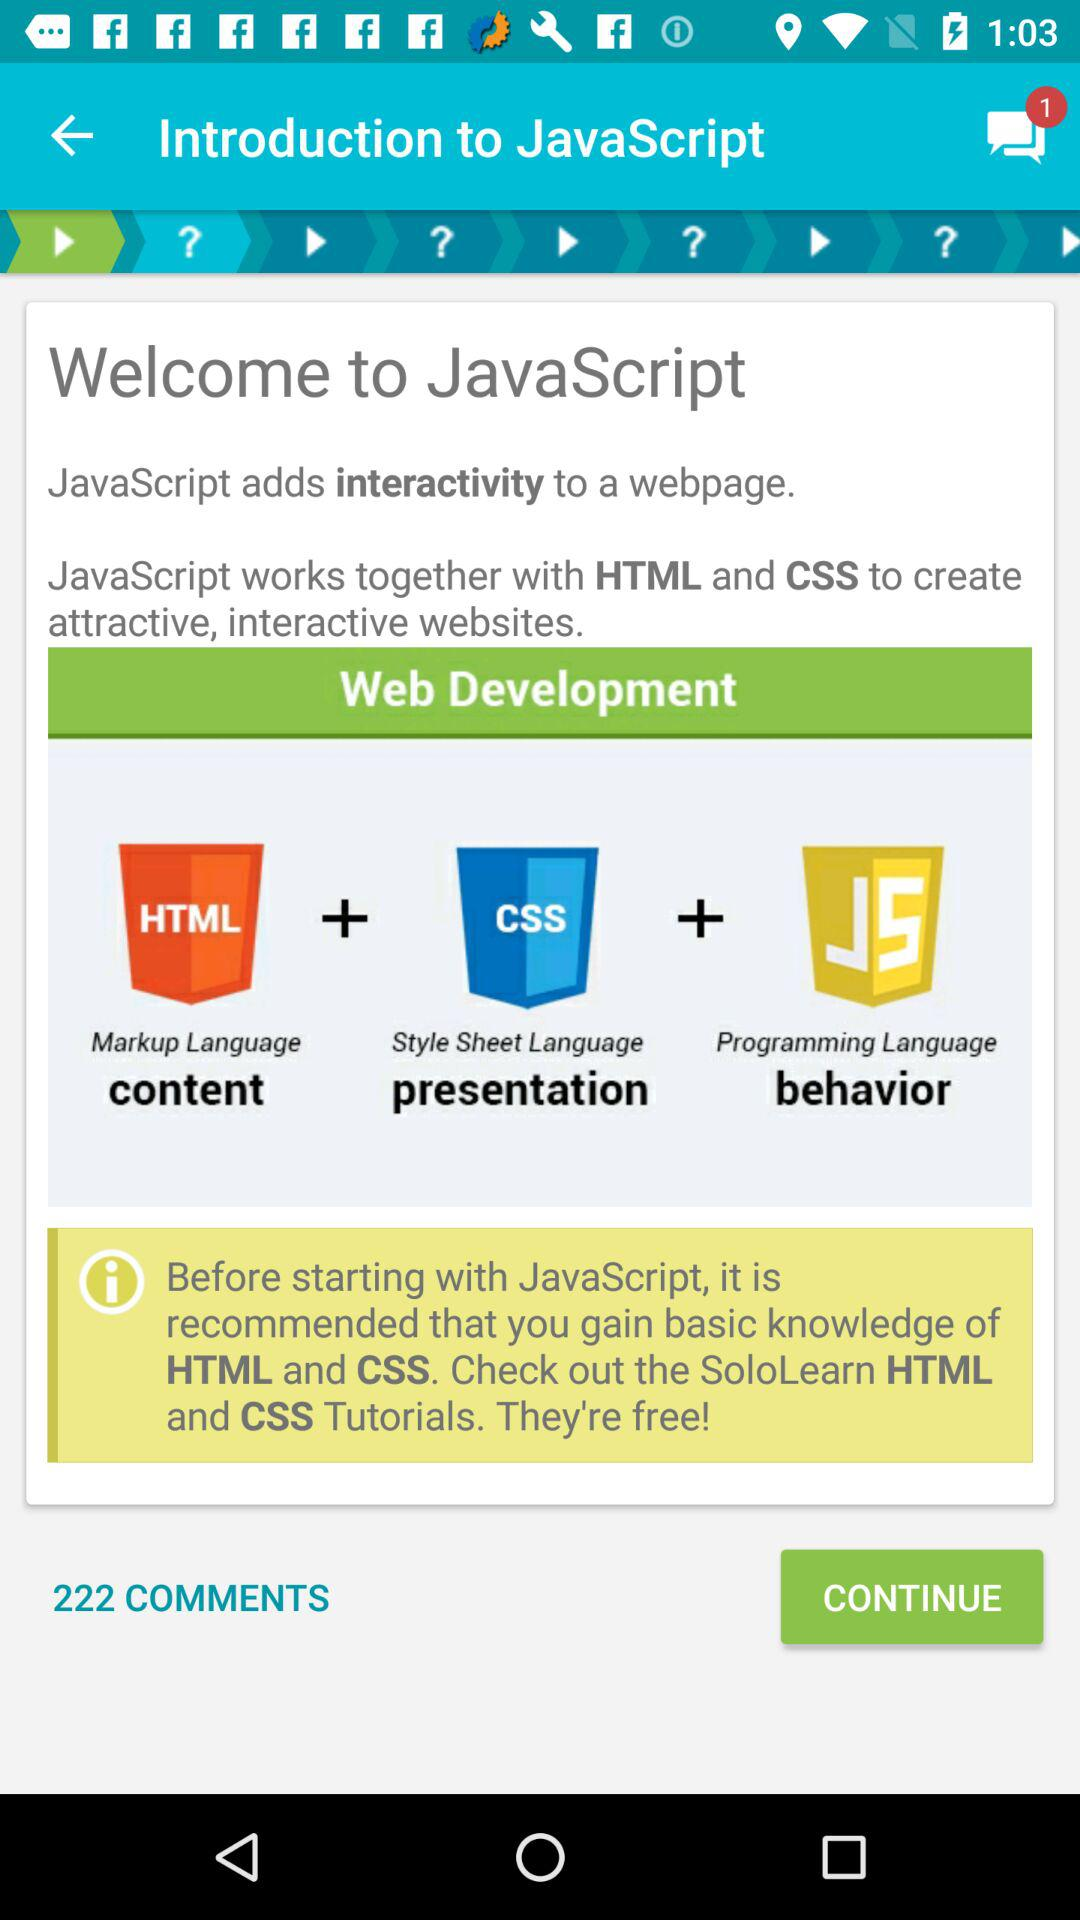Who is the user?
When the provided information is insufficient, respond with <no answer>. <no answer> 